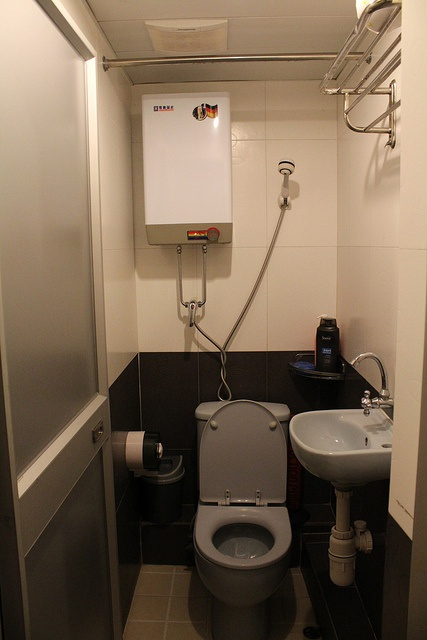Describe the objects in this image and their specific colors. I can see toilet in beige, black, gray, and maroon tones and sink in beige, gray, black, and tan tones in this image. 